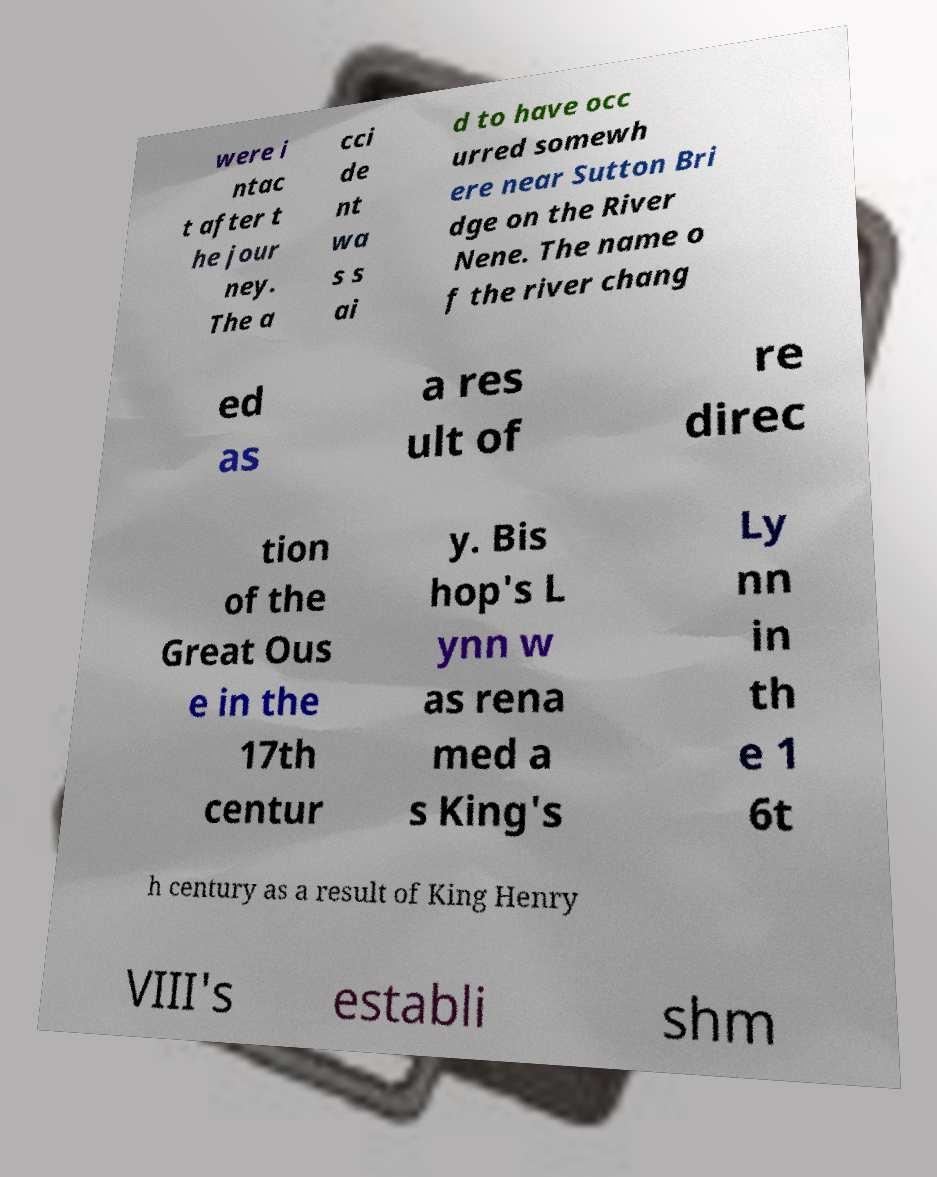Can you read and provide the text displayed in the image?This photo seems to have some interesting text. Can you extract and type it out for me? were i ntac t after t he jour ney. The a cci de nt wa s s ai d to have occ urred somewh ere near Sutton Bri dge on the River Nene. The name o f the river chang ed as a res ult of re direc tion of the Great Ous e in the 17th centur y. Bis hop's L ynn w as rena med a s King's Ly nn in th e 1 6t h century as a result of King Henry VIII's establi shm 